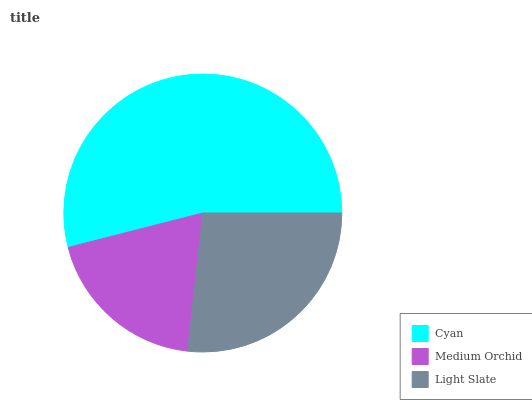Is Medium Orchid the minimum?
Answer yes or no. Yes. Is Cyan the maximum?
Answer yes or no. Yes. Is Light Slate the minimum?
Answer yes or no. No. Is Light Slate the maximum?
Answer yes or no. No. Is Light Slate greater than Medium Orchid?
Answer yes or no. Yes. Is Medium Orchid less than Light Slate?
Answer yes or no. Yes. Is Medium Orchid greater than Light Slate?
Answer yes or no. No. Is Light Slate less than Medium Orchid?
Answer yes or no. No. Is Light Slate the high median?
Answer yes or no. Yes. Is Light Slate the low median?
Answer yes or no. Yes. Is Medium Orchid the high median?
Answer yes or no. No. Is Medium Orchid the low median?
Answer yes or no. No. 